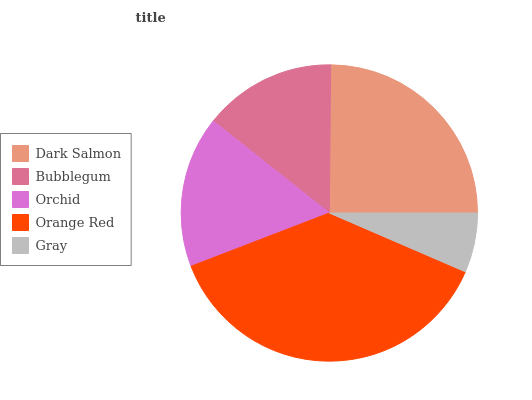Is Gray the minimum?
Answer yes or no. Yes. Is Orange Red the maximum?
Answer yes or no. Yes. Is Bubblegum the minimum?
Answer yes or no. No. Is Bubblegum the maximum?
Answer yes or no. No. Is Dark Salmon greater than Bubblegum?
Answer yes or no. Yes. Is Bubblegum less than Dark Salmon?
Answer yes or no. Yes. Is Bubblegum greater than Dark Salmon?
Answer yes or no. No. Is Dark Salmon less than Bubblegum?
Answer yes or no. No. Is Orchid the high median?
Answer yes or no. Yes. Is Orchid the low median?
Answer yes or no. Yes. Is Orange Red the high median?
Answer yes or no. No. Is Gray the low median?
Answer yes or no. No. 